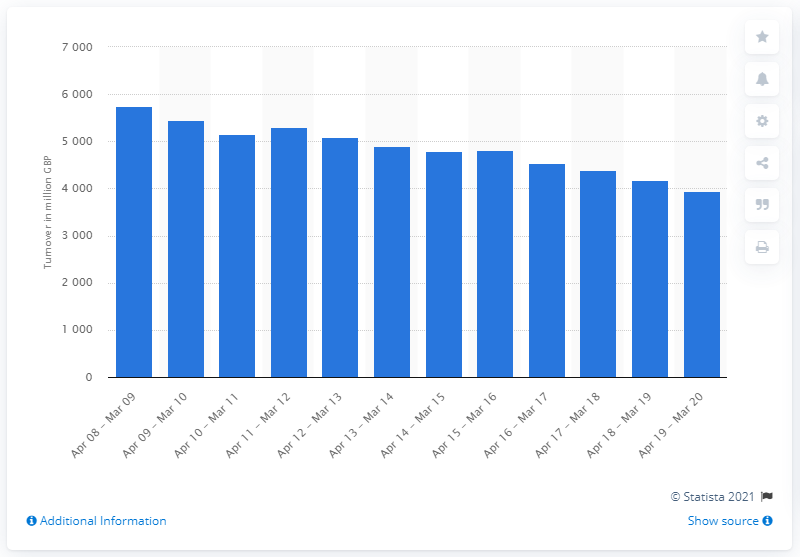Mention a couple of crucial points in this snapshot. In the United Kingdom in 2009, the turnover from off-course horse race betting was £57,43.51. 